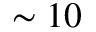Convert formula to latex. <formula><loc_0><loc_0><loc_500><loc_500>\sim 1 0</formula> 